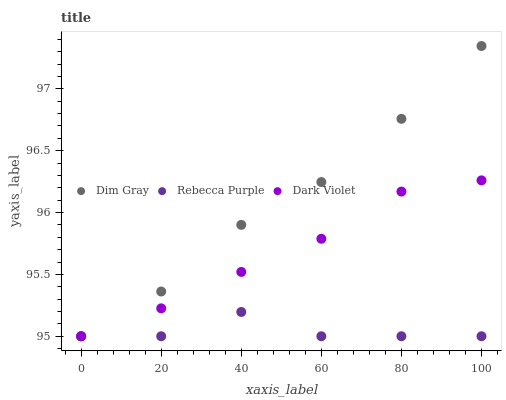Does Rebecca Purple have the minimum area under the curve?
Answer yes or no. Yes. Does Dim Gray have the maximum area under the curve?
Answer yes or no. Yes. Does Dark Violet have the minimum area under the curve?
Answer yes or no. No. Does Dark Violet have the maximum area under the curve?
Answer yes or no. No. Is Dark Violet the smoothest?
Answer yes or no. Yes. Is Rebecca Purple the roughest?
Answer yes or no. Yes. Is Rebecca Purple the smoothest?
Answer yes or no. No. Is Dark Violet the roughest?
Answer yes or no. No. Does Dim Gray have the lowest value?
Answer yes or no. Yes. Does Dim Gray have the highest value?
Answer yes or no. Yes. Does Dark Violet have the highest value?
Answer yes or no. No. Does Dark Violet intersect Rebecca Purple?
Answer yes or no. Yes. Is Dark Violet less than Rebecca Purple?
Answer yes or no. No. Is Dark Violet greater than Rebecca Purple?
Answer yes or no. No. 